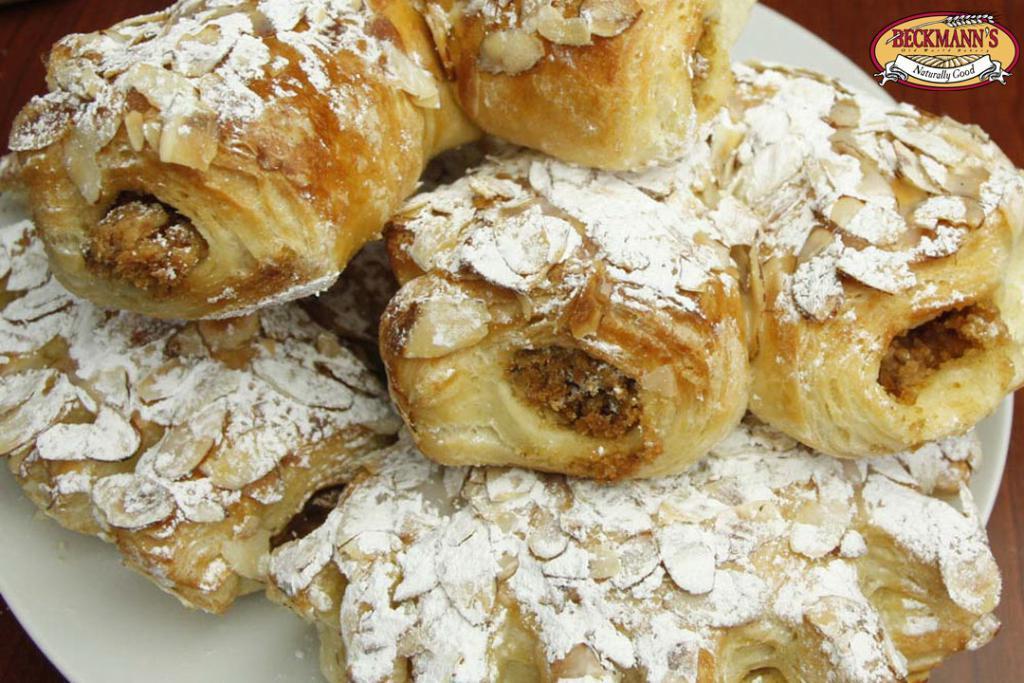Can you describe this image briefly? In this image, we can see there are puffs, on which there are some ingredients arranged on a white color plate. On the top left, there is a watermark. And the background is brown in color. 